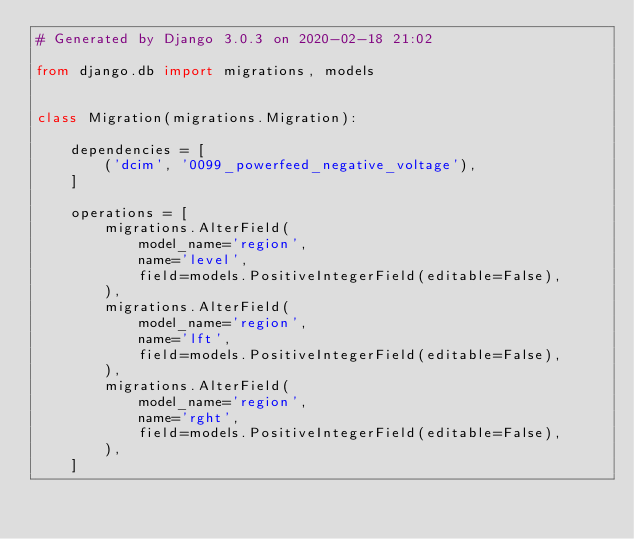Convert code to text. <code><loc_0><loc_0><loc_500><loc_500><_Python_># Generated by Django 3.0.3 on 2020-02-18 21:02

from django.db import migrations, models


class Migration(migrations.Migration):

    dependencies = [
        ('dcim', '0099_powerfeed_negative_voltage'),
    ]

    operations = [
        migrations.AlterField(
            model_name='region',
            name='level',
            field=models.PositiveIntegerField(editable=False),
        ),
        migrations.AlterField(
            model_name='region',
            name='lft',
            field=models.PositiveIntegerField(editable=False),
        ),
        migrations.AlterField(
            model_name='region',
            name='rght',
            field=models.PositiveIntegerField(editable=False),
        ),
    ]
</code> 